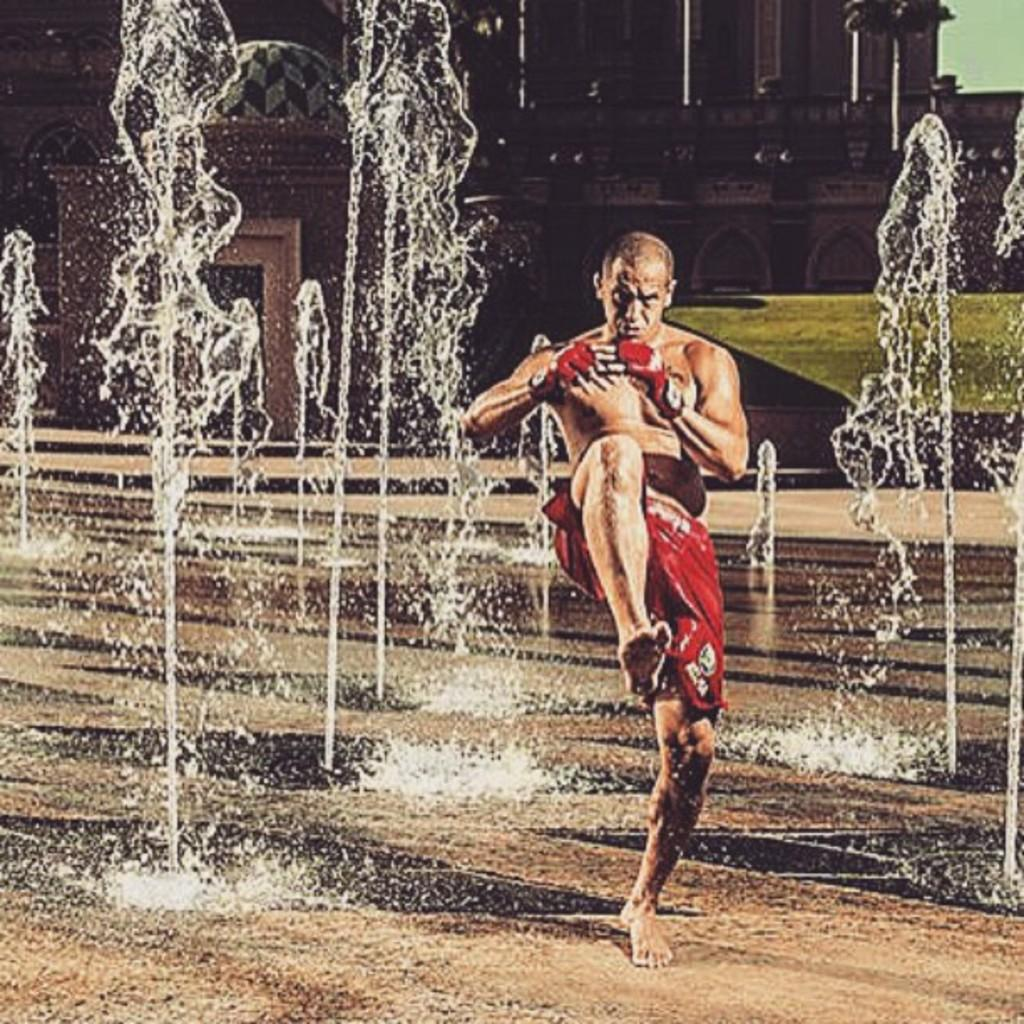What can be seen in the background of the image? There is a building in the background of the image. Can you describe the person in the image? A person is standing in the image. How many passengers are on the boats in the image? There are no boats present in the image; it only features a building in the background and a person standing. 